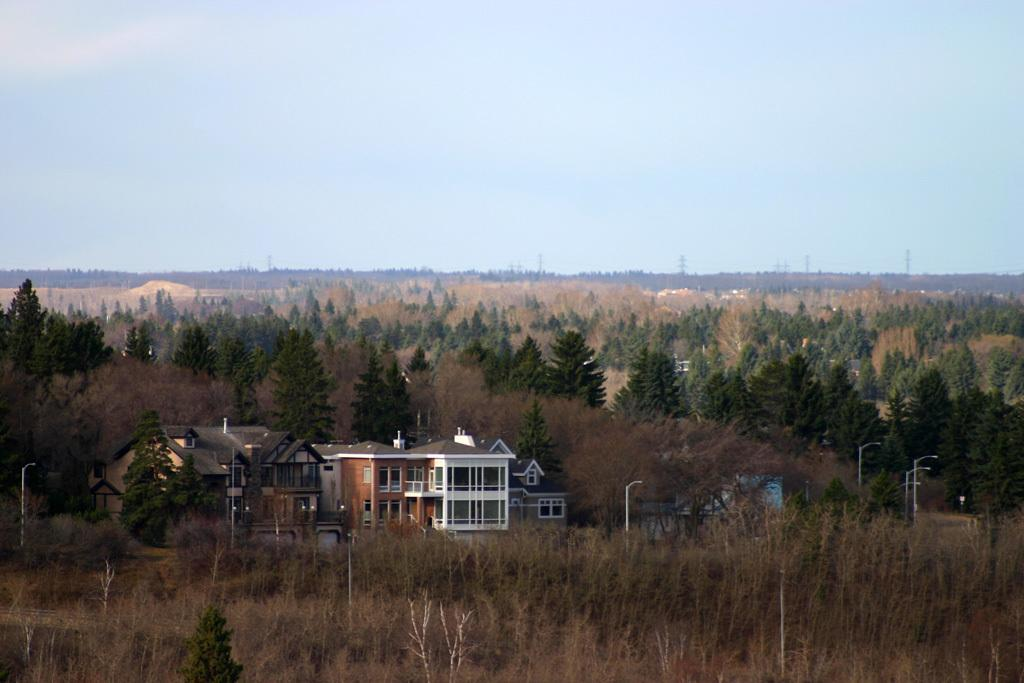What types of vegetation can be seen in the image? There are plants and trees in the image. What structures are present in the image? There are buildings in the image. What objects can be seen on the ground in the image? There are poles on the ground in the image. What is visible in the sky in the background of the image? There are clouds in the sky in the background of the image. What type of ornament is hanging from the building in the image? There is no ornament hanging from the building in the image; only the plants, trees, buildings, poles, and clouds are present. 